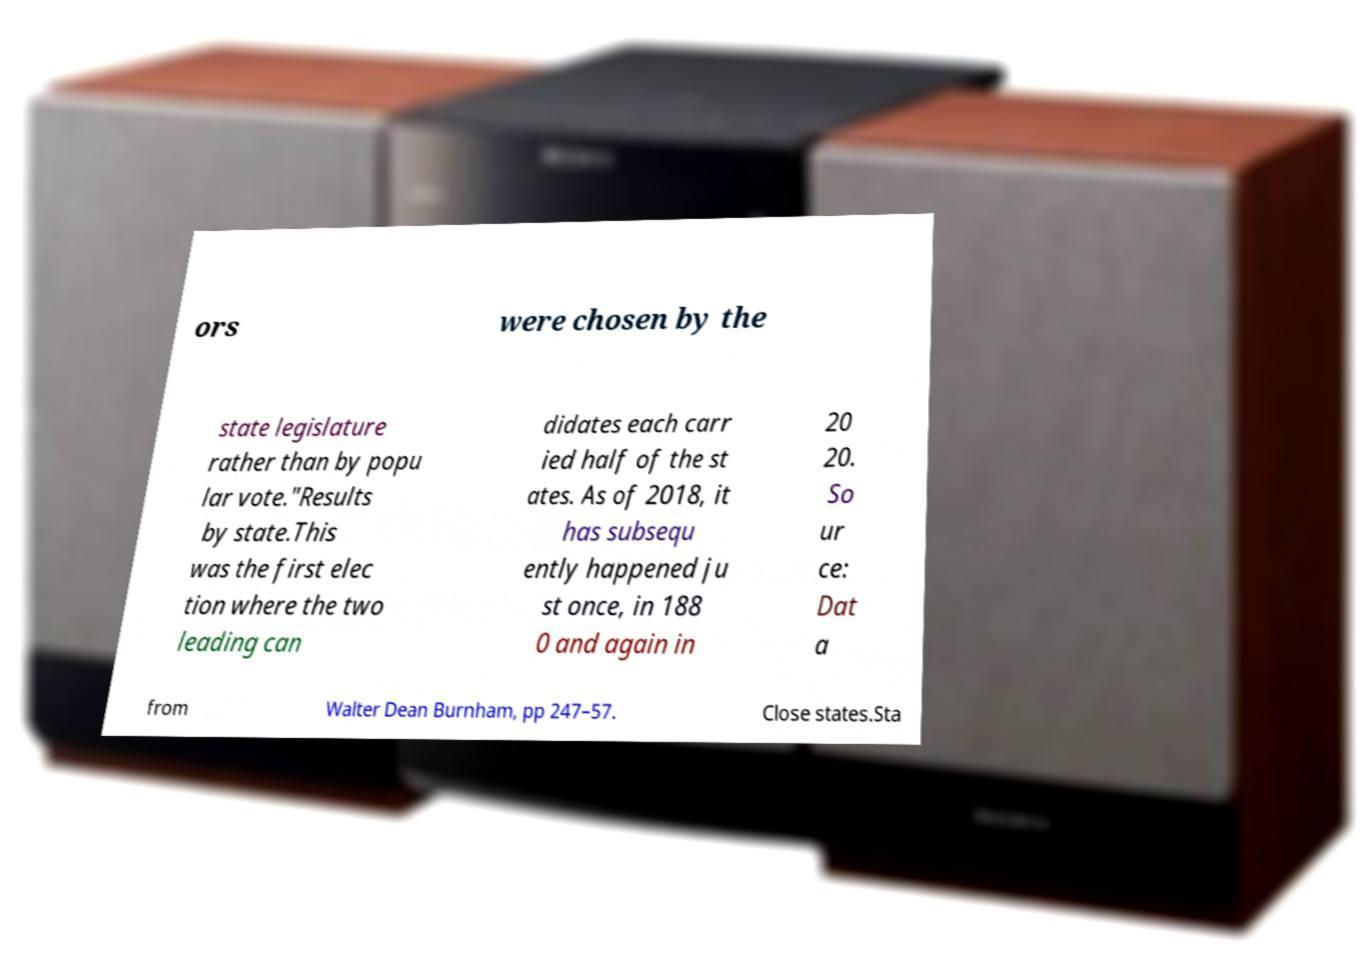For documentation purposes, I need the text within this image transcribed. Could you provide that? ors were chosen by the state legislature rather than by popu lar vote."Results by state.This was the first elec tion where the two leading can didates each carr ied half of the st ates. As of 2018, it has subsequ ently happened ju st once, in 188 0 and again in 20 20. So ur ce: Dat a from Walter Dean Burnham, pp 247–57. Close states.Sta 